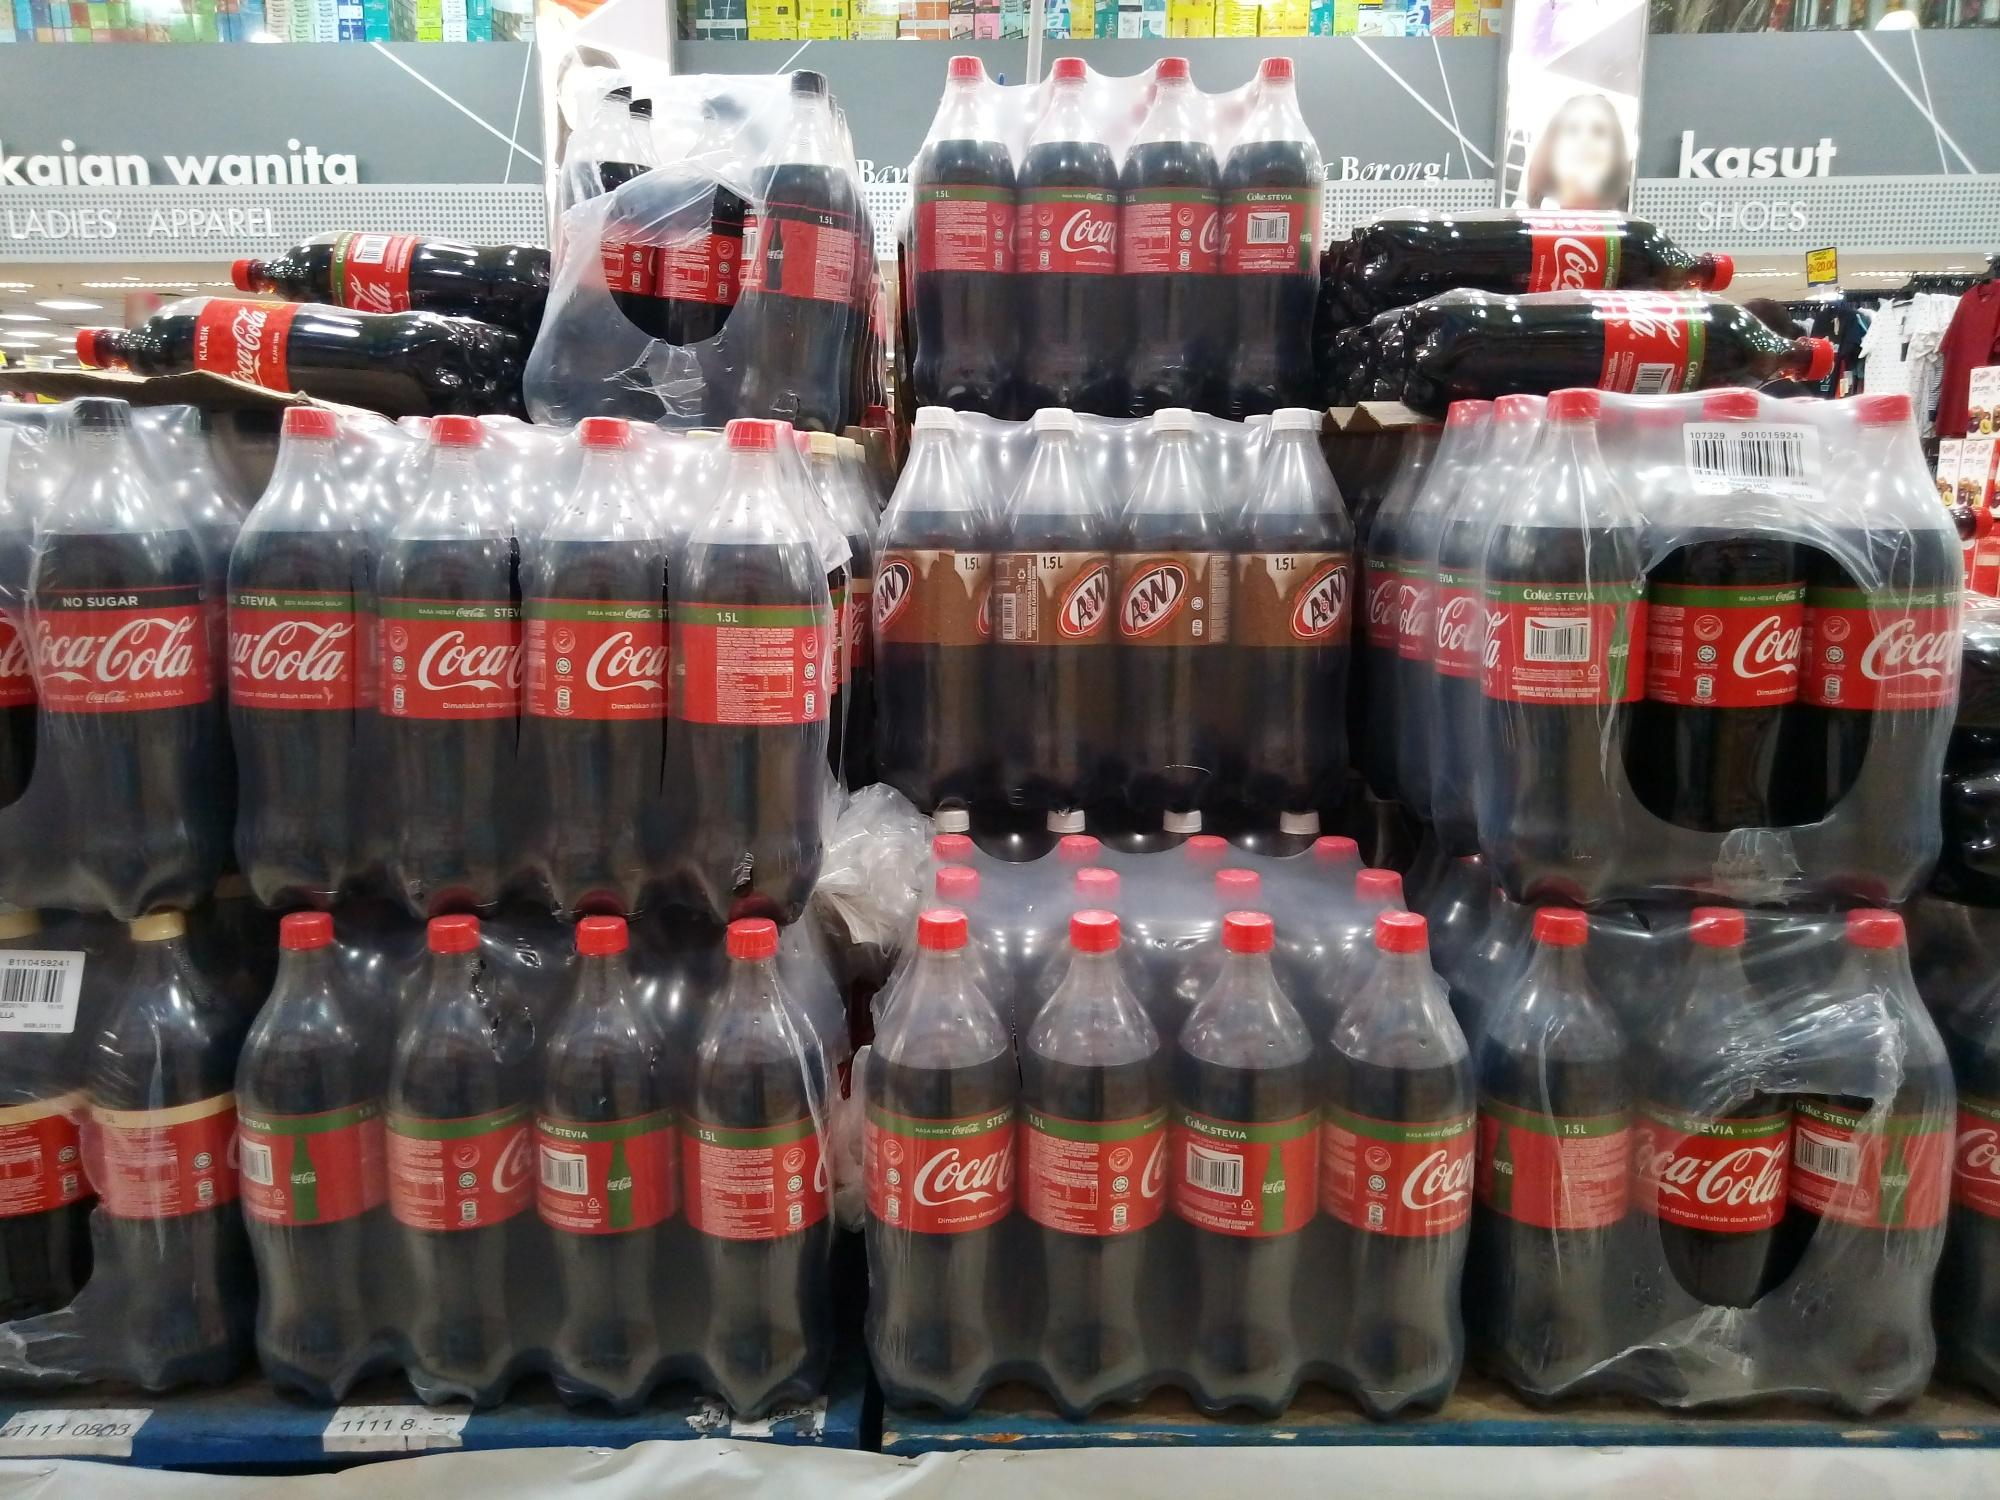Realistic scenario: A family choosing drinks for a barbecue. A family strolls through the store, excitedly discussing their upcoming weekend barbecue. As they pass by the pyramid of Coca-Cola and A&W bottles, they pause, deliberating on their drink choices. The children eagerly point to the Coca-Cola bottles, enchanted by the bright red labels and familiar taste they associate with fun gatherings. The parents consider the A&W bottles, thinking of how the root beer would be a hit with their friends. They carefully select a mix of both, ensuring there's something to please everyone at the barbecue. With their drink selection complete, they continue their shopping, chatting animatedly about the festivities ahead. 